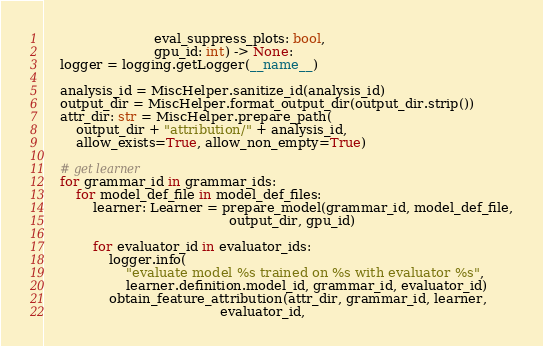<code> <loc_0><loc_0><loc_500><loc_500><_Python_>                           eval_suppress_plots: bool,
                           gpu_id: int) -> None:
    logger = logging.getLogger(__name__)

    analysis_id = MiscHelper.sanitize_id(analysis_id)
    output_dir = MiscHelper.format_output_dir(output_dir.strip())
    attr_dir: str = MiscHelper.prepare_path(
        output_dir + "attribution/" + analysis_id,
        allow_exists=True, allow_non_empty=True)

    # get learner
    for grammar_id in grammar_ids:
        for model_def_file in model_def_files:
            learner: Learner = prepare_model(grammar_id, model_def_file,
                                             output_dir, gpu_id)

            for evaluator_id in evaluator_ids:
                logger.info(
                    "evaluate model %s trained on %s with evaluator %s",
                    learner.definition.model_id, grammar_id, evaluator_id)
                obtain_feature_attribution(attr_dir, grammar_id, learner,
                                           evaluator_id,</code> 